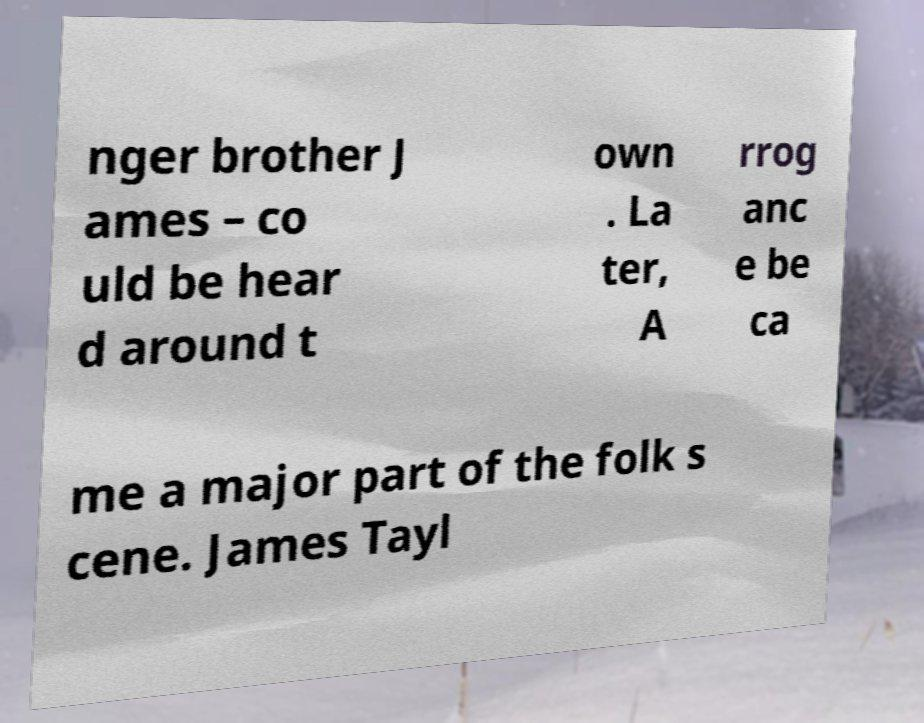Can you accurately transcribe the text from the provided image for me? nger brother J ames – co uld be hear d around t own . La ter, A rrog anc e be ca me a major part of the folk s cene. James Tayl 